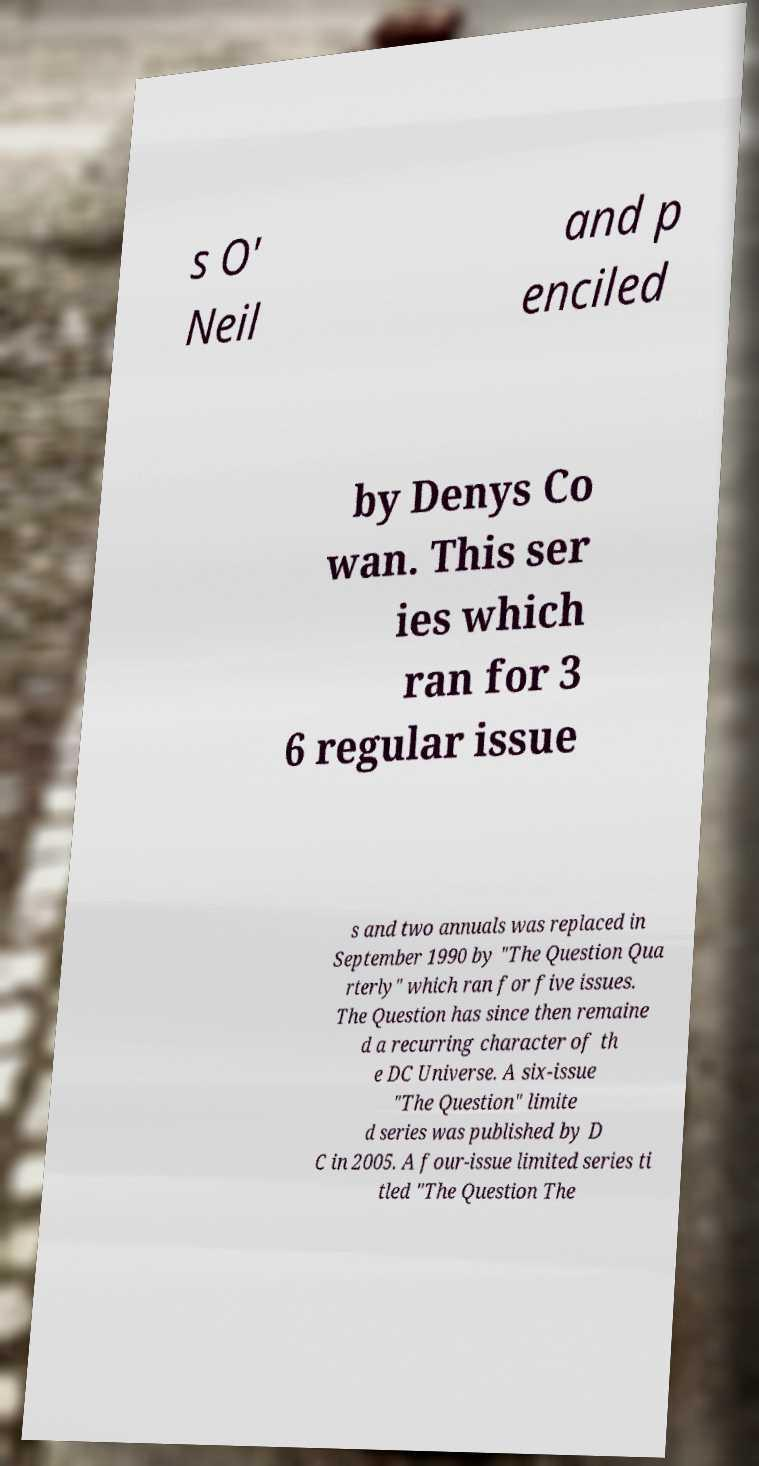Could you assist in decoding the text presented in this image and type it out clearly? s O' Neil and p enciled by Denys Co wan. This ser ies which ran for 3 6 regular issue s and two annuals was replaced in September 1990 by "The Question Qua rterly" which ran for five issues. The Question has since then remaine d a recurring character of th e DC Universe. A six-issue "The Question" limite d series was published by D C in 2005. A four-issue limited series ti tled "The Question The 